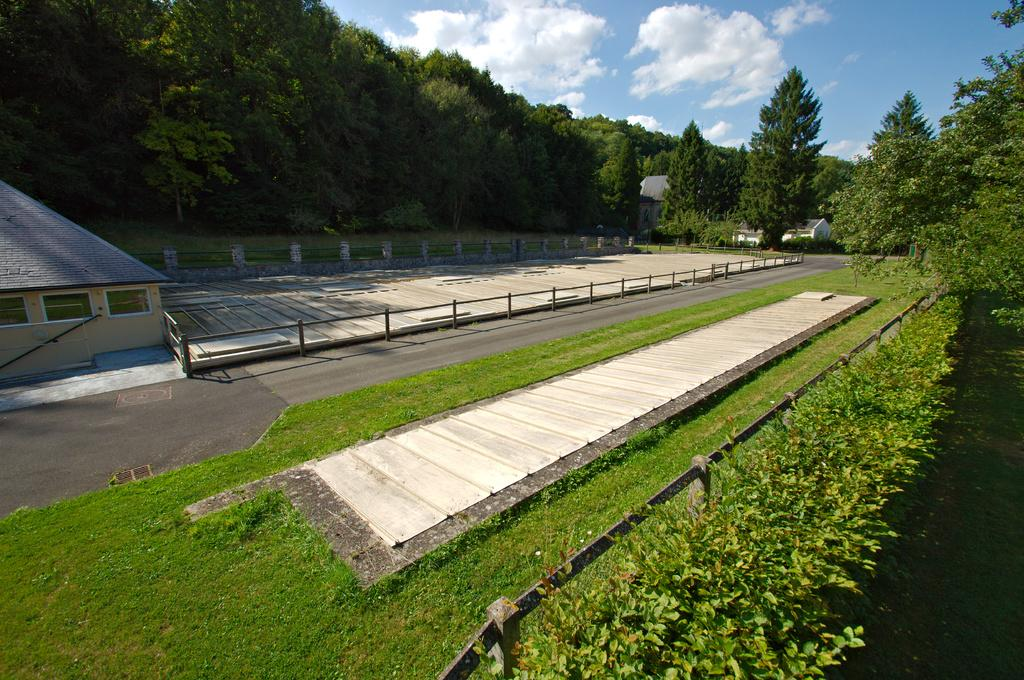What type of vegetation is in the front of the image? There are plants in the front of the image. What covers the ground in the image? There is grass on the ground. What can be seen in the background of the image? There are trees and houses in the background of the image. What is the condition of the sky in the image? The sky is cloudy in the image. What company's logo can be seen on the plants in the image? There is no company logo present on the plants in the image. Can you tell me how many noses are visible in the image? There are no noses visible in the image. 